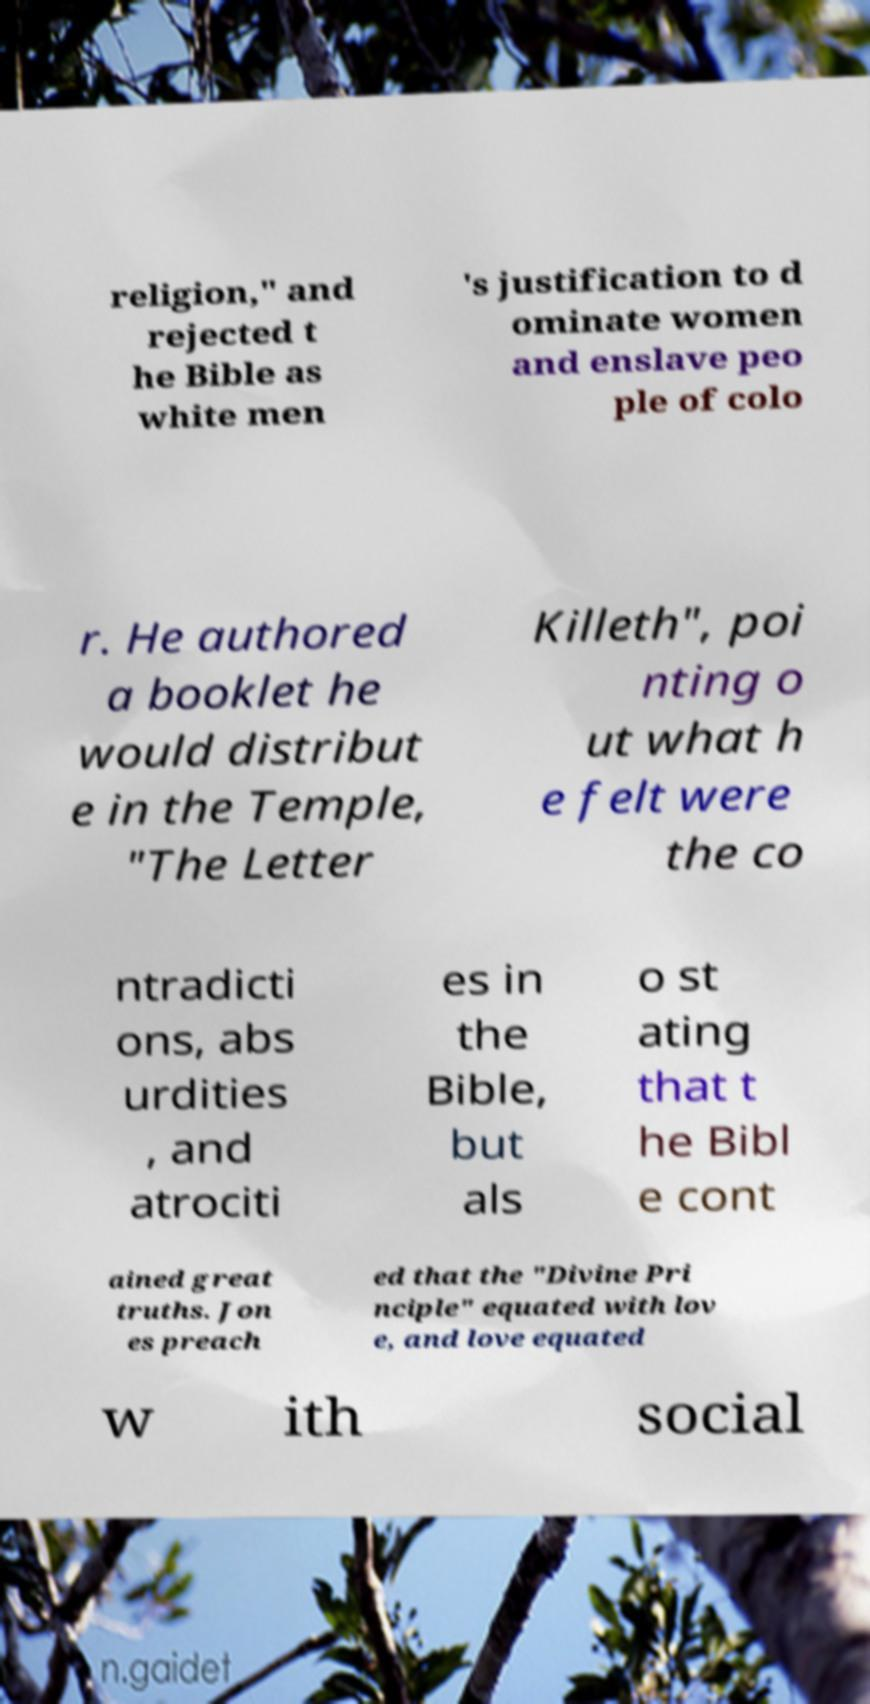Could you extract and type out the text from this image? religion," and rejected t he Bible as white men 's justification to d ominate women and enslave peo ple of colo r. He authored a booklet he would distribut e in the Temple, "The Letter Killeth", poi nting o ut what h e felt were the co ntradicti ons, abs urdities , and atrociti es in the Bible, but als o st ating that t he Bibl e cont ained great truths. Jon es preach ed that the "Divine Pri nciple" equated with lov e, and love equated w ith social 